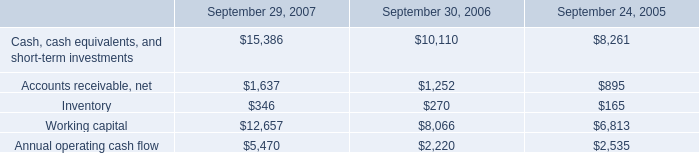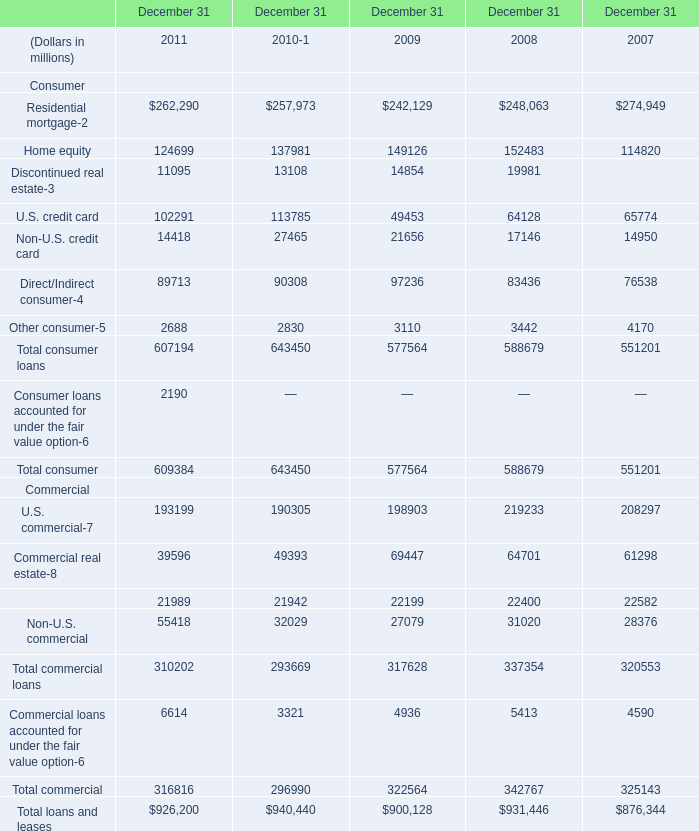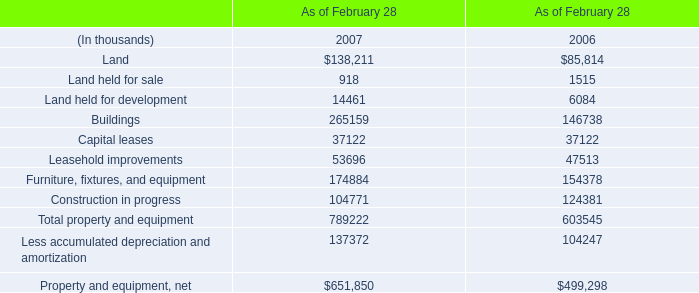what's the total amount of Accounts receivable, net of September 30, 2006, Discontinued real estate of December 31 2009, and Commercial lease financing Commercial of December 31 2011 ? 
Computations: ((1252.0 + 14854.0) + 21989.0)
Answer: 38095.0. 